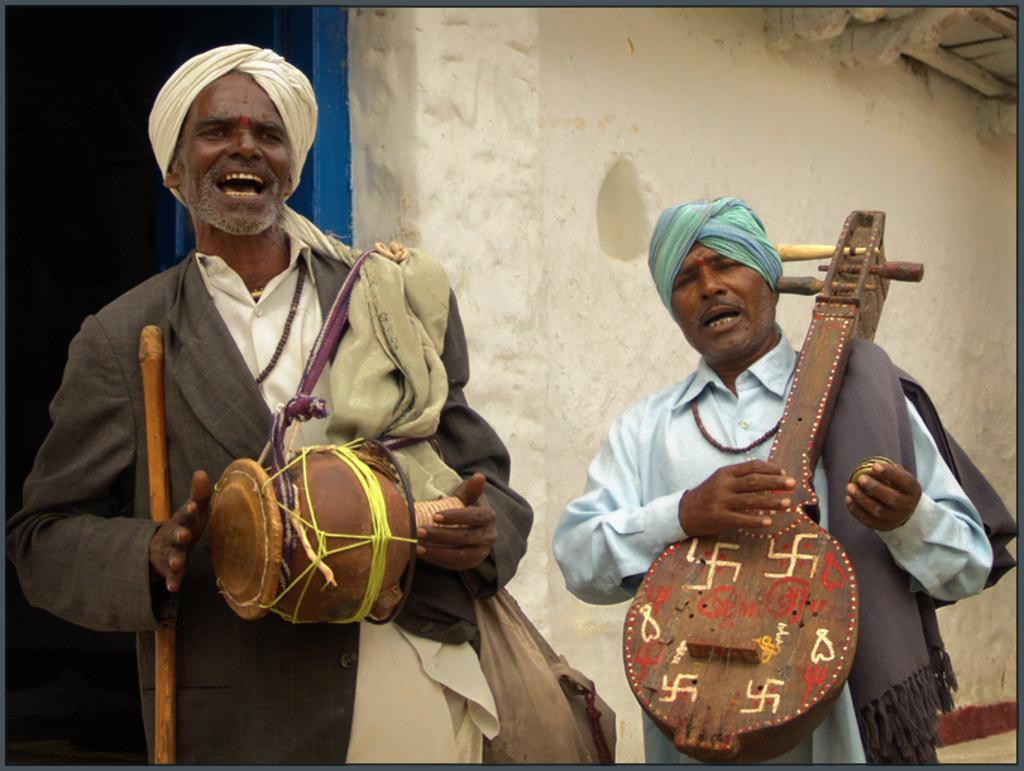How many people are in the image? There are two men in the image. What are the men doing in the image? The men are standing, holding and playing musical instruments, and singing. Can you describe the background of the image? There is a white color wall, a blue color door, and a roof in the background. What type of pancake can be smelled in the image? There is no pancake present in the image, and therefore no smell can be associated with it. What mode of transportation are the men using in the image? The image does not show any mode of transportation; it features two men playing musical instruments and singing. 